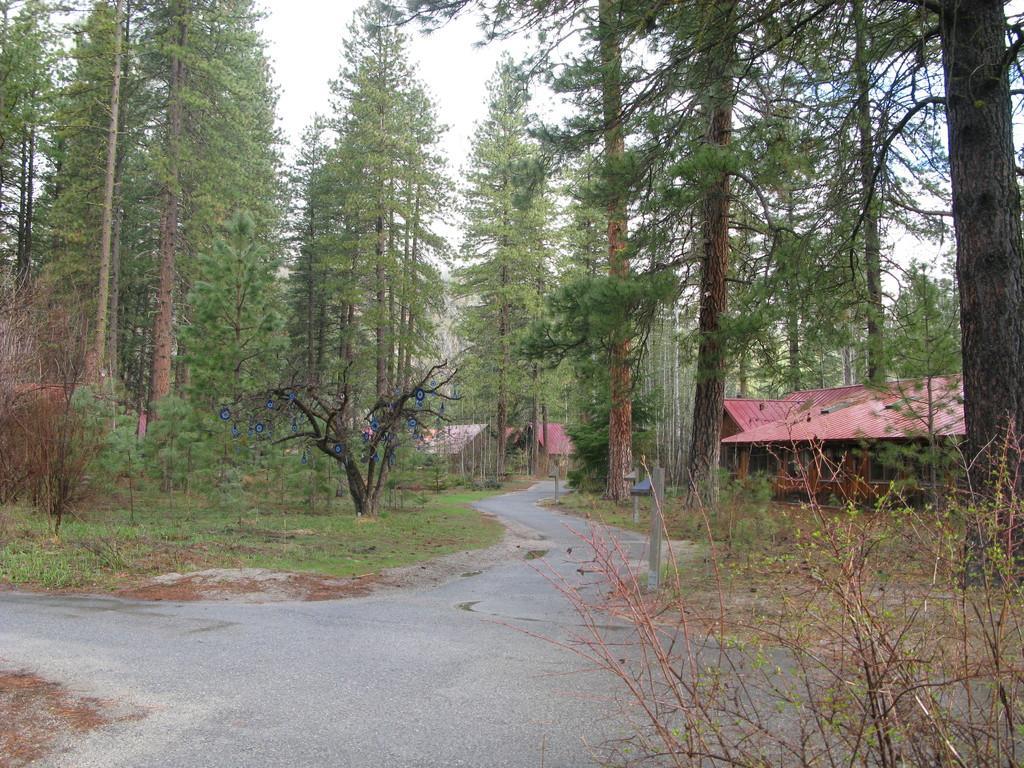Could you give a brief overview of what you see in this image? This image consists of a road. And we can see many trees. On the right, there are houses. At the top, there is sky. 